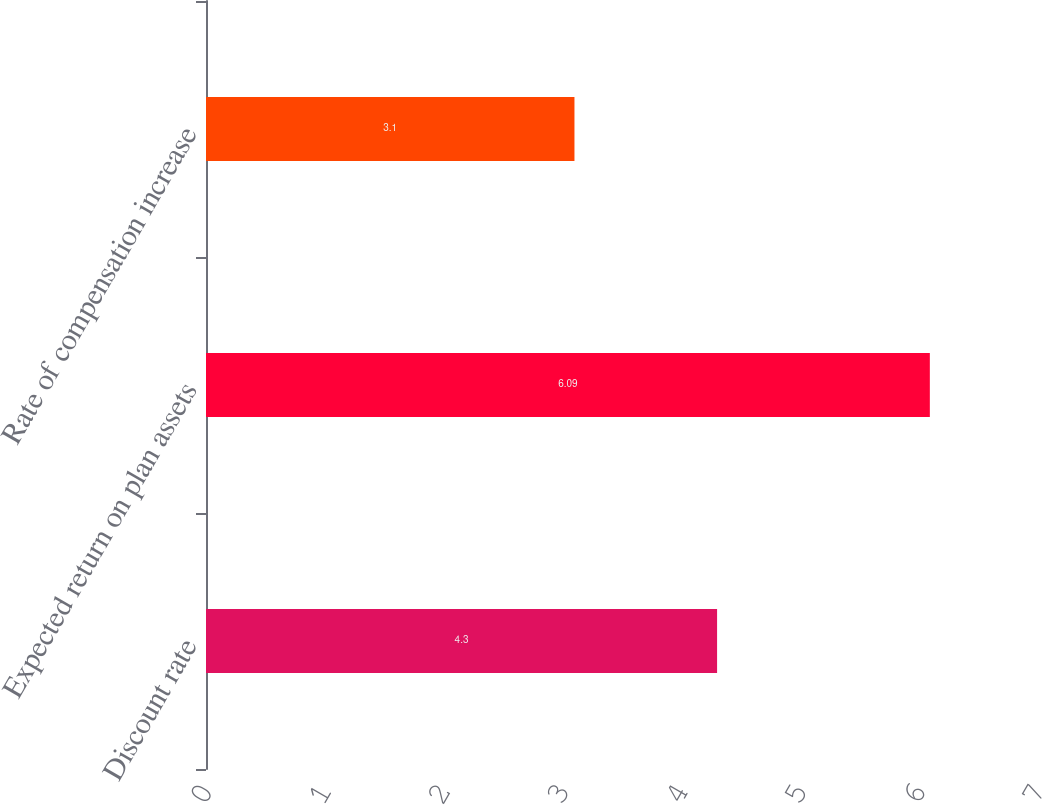<chart> <loc_0><loc_0><loc_500><loc_500><bar_chart><fcel>Discount rate<fcel>Expected return on plan assets<fcel>Rate of compensation increase<nl><fcel>4.3<fcel>6.09<fcel>3.1<nl></chart> 